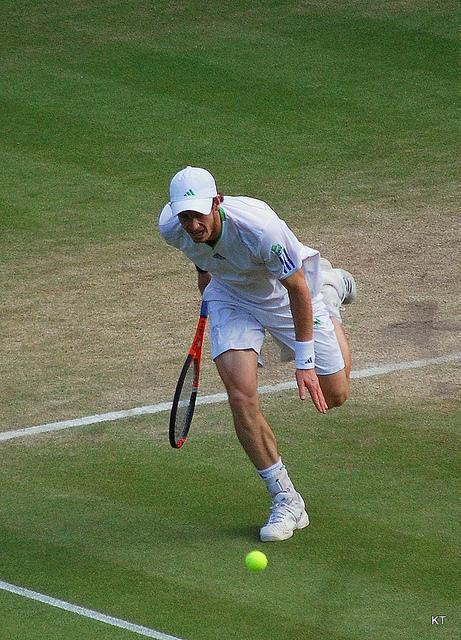How many elephant do you see?
Give a very brief answer. 0. 